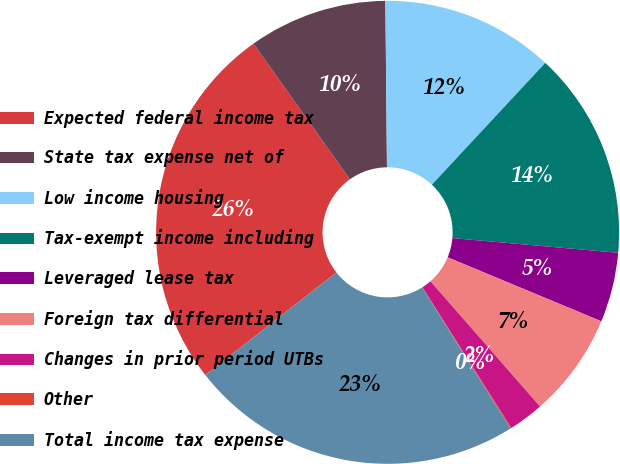<chart> <loc_0><loc_0><loc_500><loc_500><pie_chart><fcel>Expected federal income tax<fcel>State tax expense net of<fcel>Low income housing<fcel>Tax-exempt income including<fcel>Leveraged lease tax<fcel>Foreign tax differential<fcel>Changes in prior period UTBs<fcel>Other<fcel>Total income tax expense<nl><fcel>25.74%<fcel>9.68%<fcel>12.08%<fcel>14.48%<fcel>4.87%<fcel>7.28%<fcel>2.47%<fcel>0.07%<fcel>23.33%<nl></chart> 